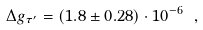Convert formula to latex. <formula><loc_0><loc_0><loc_500><loc_500>\Delta g _ { \tau ^ { \prime } } = ( 1 . 8 \pm 0 . 2 8 ) \cdot 1 0 ^ { - 6 } \ ,</formula> 